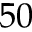Convert formula to latex. <formula><loc_0><loc_0><loc_500><loc_500>5 0</formula> 